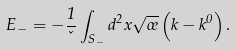Convert formula to latex. <formula><loc_0><loc_0><loc_500><loc_500>E _ { - } = - \frac { 1 } { \kappa } \int _ { S _ { - } } d ^ { 2 } x \sqrt { \sigma } \left ( k - k ^ { 0 } \right ) .</formula> 